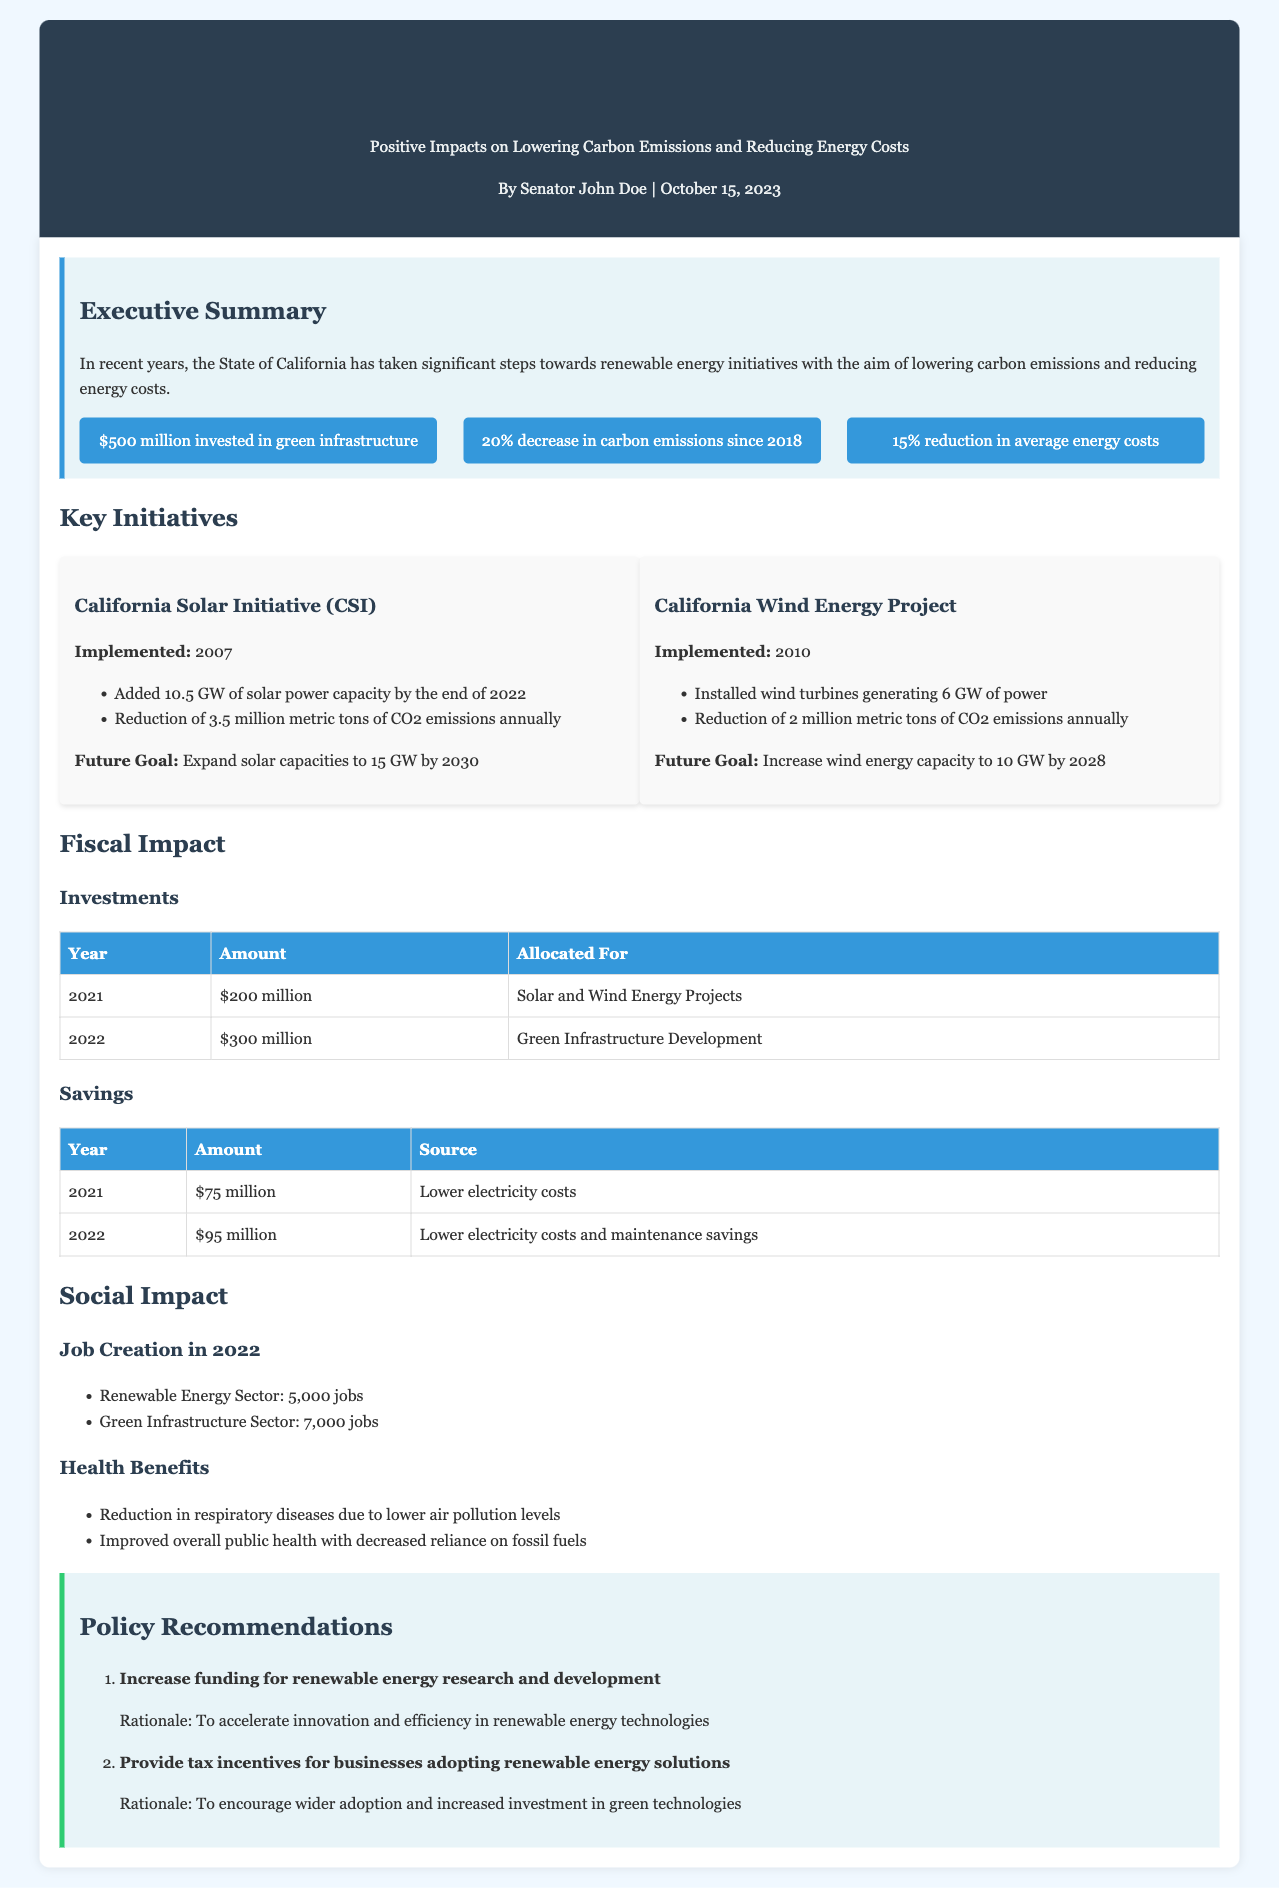what is the investment amount in 2022? The investment amount in 2022 is detailed in the fiscal impact section of the document.
Answer: $300 million how much did carbon emissions decrease since 2018? The decrease in carbon emissions is stated as a percentage, which is highlighted in the key takeaways section.
Answer: 20% how many jobs were created in the renewable energy sector in 2022? The number of jobs created in the renewable energy sector is listed under the social impact section.
Answer: 5,000 what is the future goal for the California Solar Initiative? The future goal for the California Solar Initiative is specified in the initiatives section of the document.
Answer: 15 GW by 2030 what year was the California Wind Energy Project implemented? The implementation year for the California Wind Energy Project is mentioned in the initiatives section.
Answer: 2010 which initiative added 10.5 GW of solar power capacity? The initiative responsible for adding 10.5 GW of solar power capacity is provided under key initiatives.
Answer: California Solar Initiative (CSI) what is one health benefit mentioned in the report? The health benefits related to renewable energy and lower air pollution levels are listed under social impact.
Answer: Reduction in respiratory diseases what is the total amount of savings in 2022? The total savings amount is derived from the savings table provided in the fiscal impact section.
Answer: $95 million what is the rationale for increasing funding for renewable energy research? The rationale is stated in the policy recommendations section of the document.
Answer: To accelerate innovation and efficiency in renewable energy technologies 